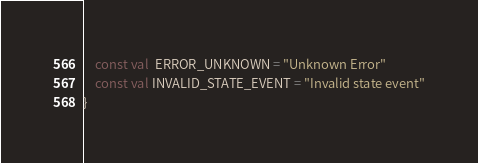<code> <loc_0><loc_0><loc_500><loc_500><_Kotlin_>    const val  ERROR_UNKNOWN = "Unknown Error"
    const val INVALID_STATE_EVENT = "Invalid state event"
}</code> 